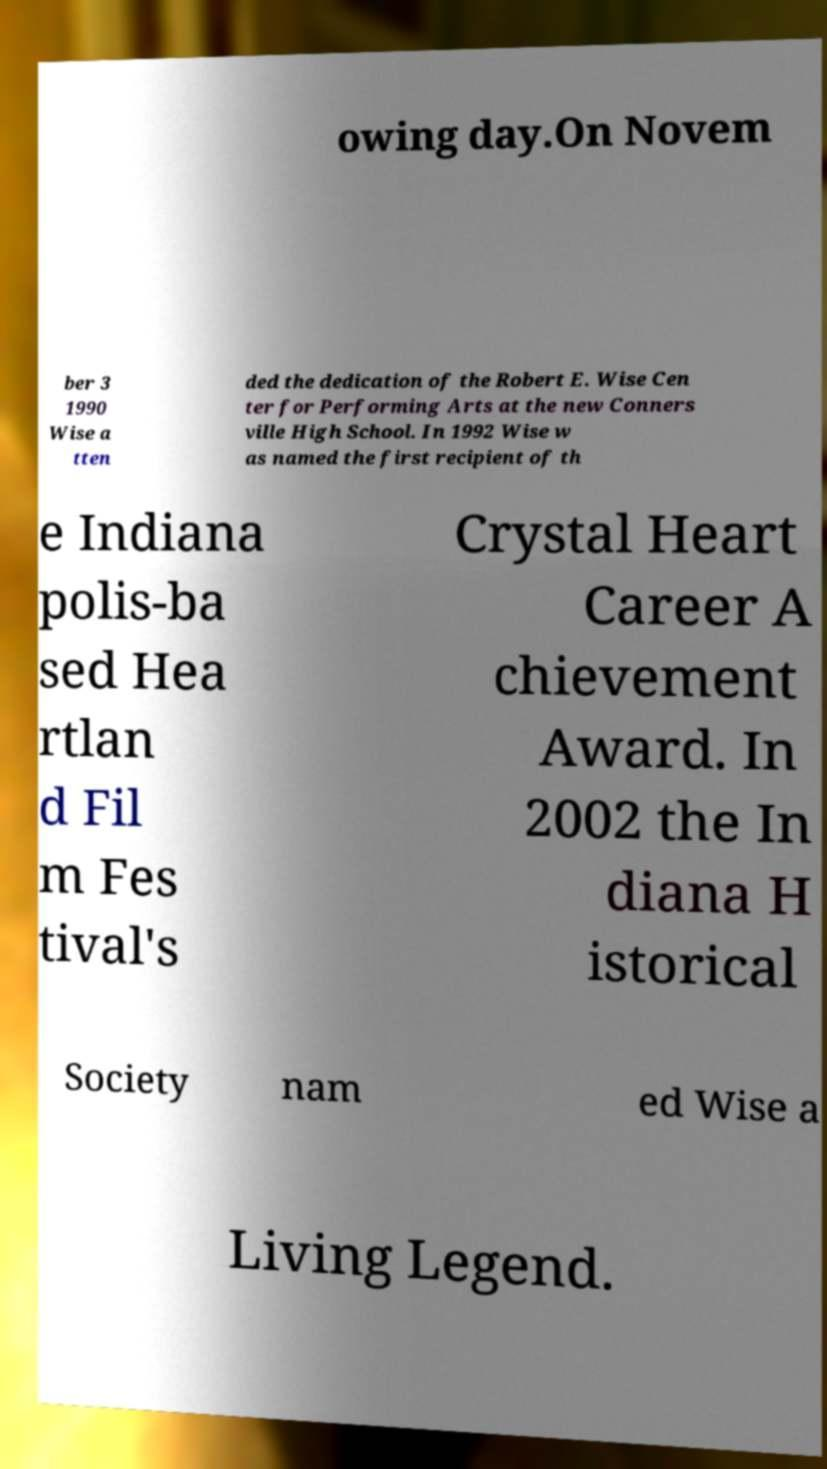I need the written content from this picture converted into text. Can you do that? owing day.On Novem ber 3 1990 Wise a tten ded the dedication of the Robert E. Wise Cen ter for Performing Arts at the new Conners ville High School. In 1992 Wise w as named the first recipient of th e Indiana polis-ba sed Hea rtlan d Fil m Fes tival's Crystal Heart Career A chievement Award. In 2002 the In diana H istorical Society nam ed Wise a Living Legend. 